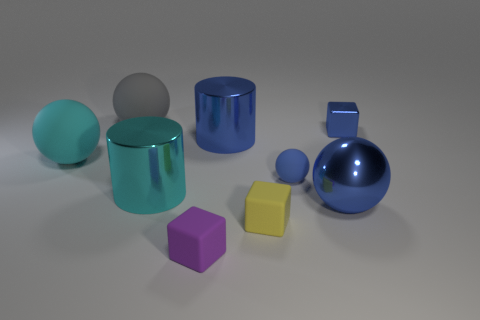What size is the metal cube that is the same color as the small rubber ball?
Ensure brevity in your answer.  Small. Is the big object that is on the left side of the big gray thing made of the same material as the big cyan object in front of the blue matte ball?
Provide a short and direct response. No. How many large rubber balls are there?
Ensure brevity in your answer.  2. The metal thing on the right side of the shiny sphere has what shape?
Your response must be concise. Cube. What number of other objects are the same size as the gray ball?
Your answer should be compact. 4. There is a thing on the left side of the gray matte sphere; is its shape the same as the blue metal object that is in front of the big cyan sphere?
Give a very brief answer. Yes. What number of blue metallic things are behind the big blue shiny cylinder?
Your response must be concise. 1. There is a tiny matte cube behind the tiny purple matte thing; what is its color?
Offer a very short reply. Yellow. The other metallic thing that is the same shape as the small purple object is what color?
Make the answer very short. Blue. Is there any other thing of the same color as the metallic ball?
Provide a succinct answer. Yes. 